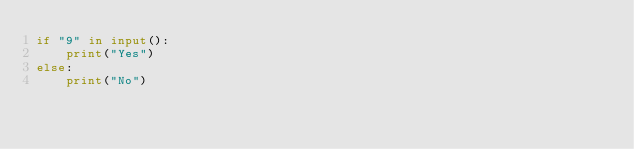<code> <loc_0><loc_0><loc_500><loc_500><_Python_>if "9" in input():
    print("Yes")
else:
    print("No")</code> 